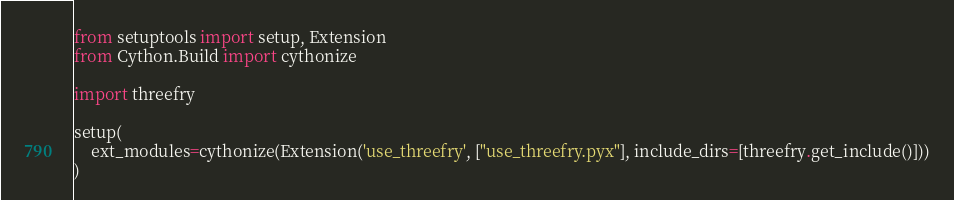<code> <loc_0><loc_0><loc_500><loc_500><_Python_>from setuptools import setup, Extension
from Cython.Build import cythonize

import threefry

setup(
    ext_modules=cythonize(Extension('use_threefry', ["use_threefry.pyx"], include_dirs=[threefry.get_include()]))
)
</code> 